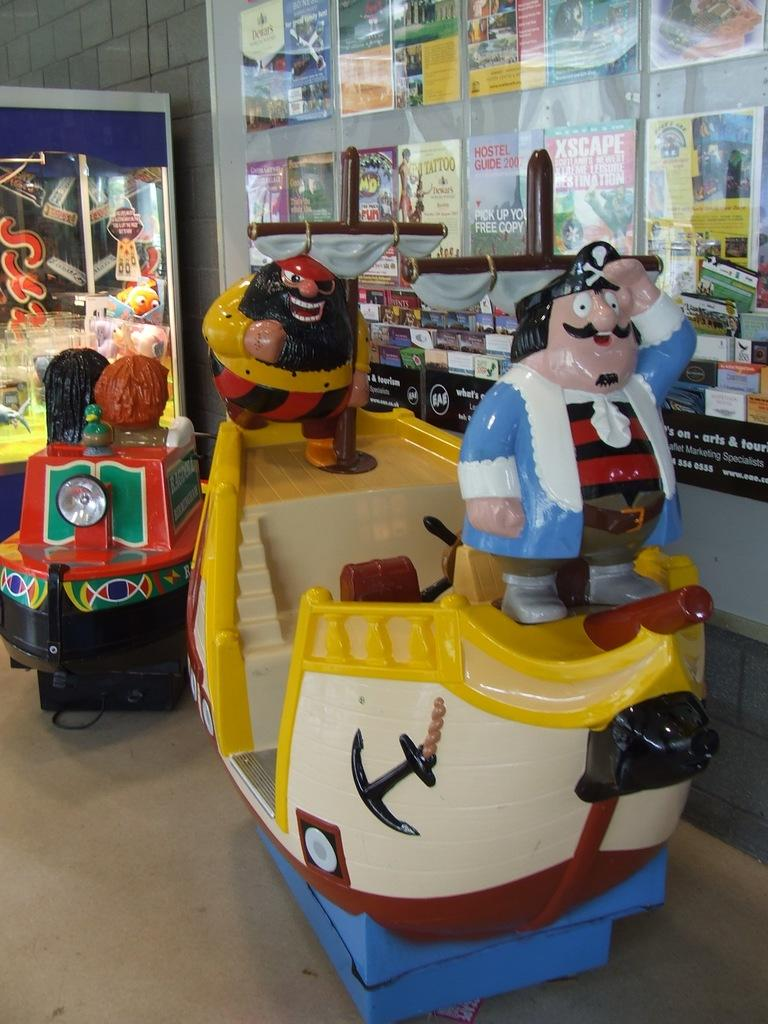<image>
Offer a succinct explanation of the picture presented. A sailor wearing a blue jacket stands in front of a 2007 Hostel Guide poster 